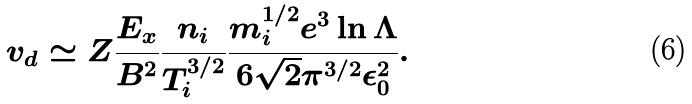<formula> <loc_0><loc_0><loc_500><loc_500>v _ { d } \simeq { Z } \frac { E _ { x } } { B ^ { 2 } } \frac { n _ { i } } { T _ { i } ^ { 3 / 2 } } \frac { m ^ { 1 / 2 } _ { i } e ^ { 3 } \ln { \Lambda } } { 6 \sqrt { 2 } \pi ^ { 3 / 2 } \epsilon ^ { 2 } _ { 0 } } .</formula> 